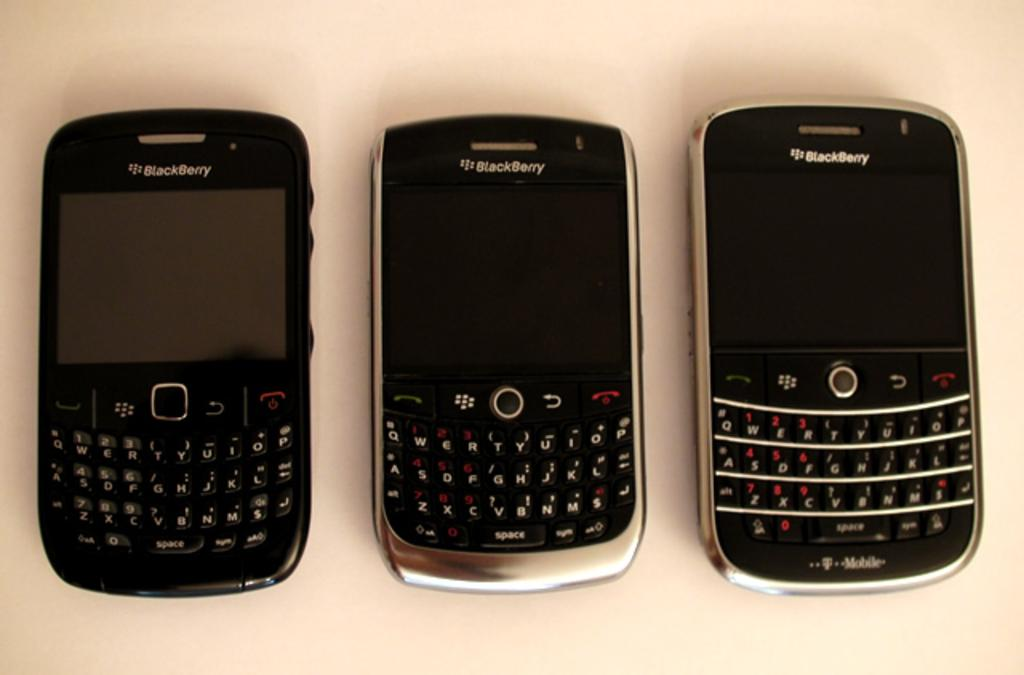<image>
Give a short and clear explanation of the subsequent image. Three Blackberry devices are powered off and sitting on a table 